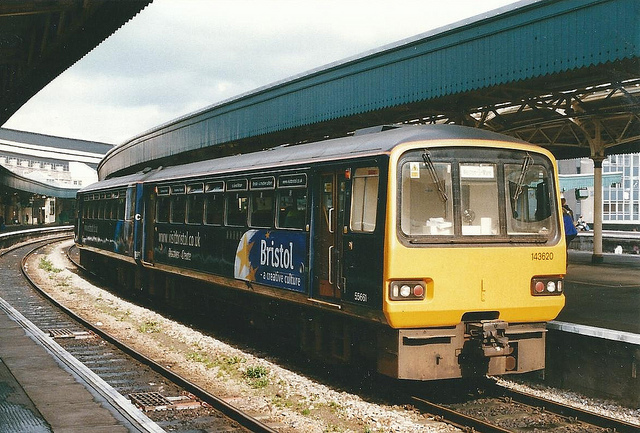Extract all visible text content from this image. Bristol C 5566 143620 